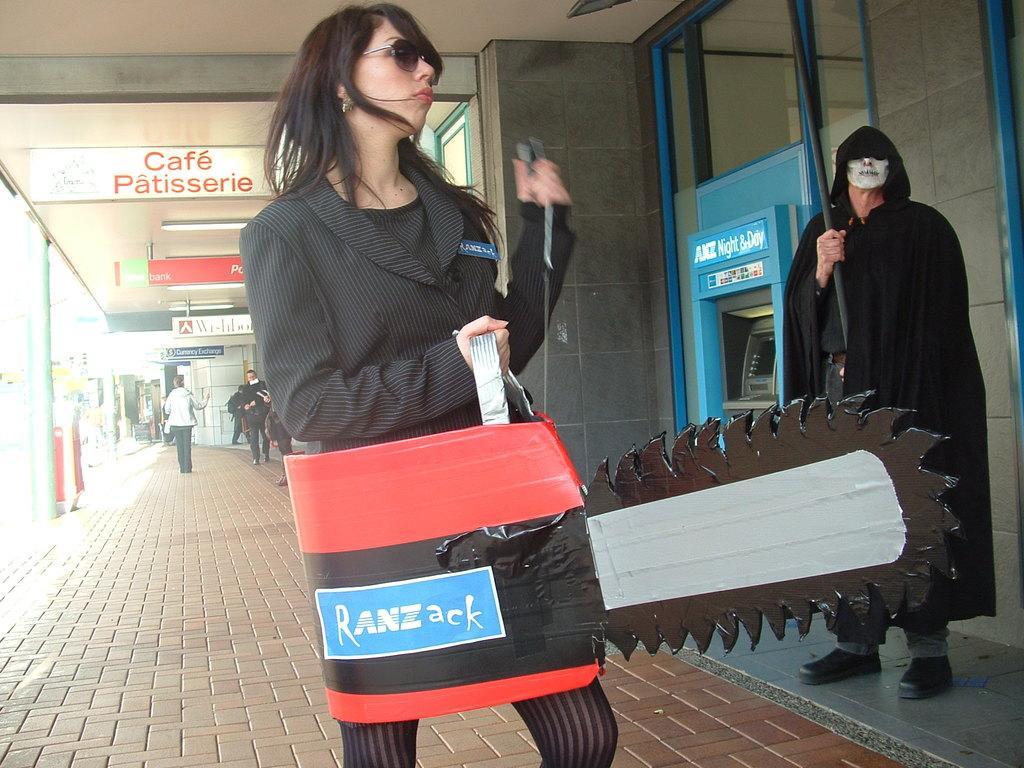Describe this image in one or two sentences. In this image there are people walking on a pavement, in the background there is a wall, near the wall a man standing wearing costumes, at the top there is a roof for that roof there are boards, on that boards there is some text. 